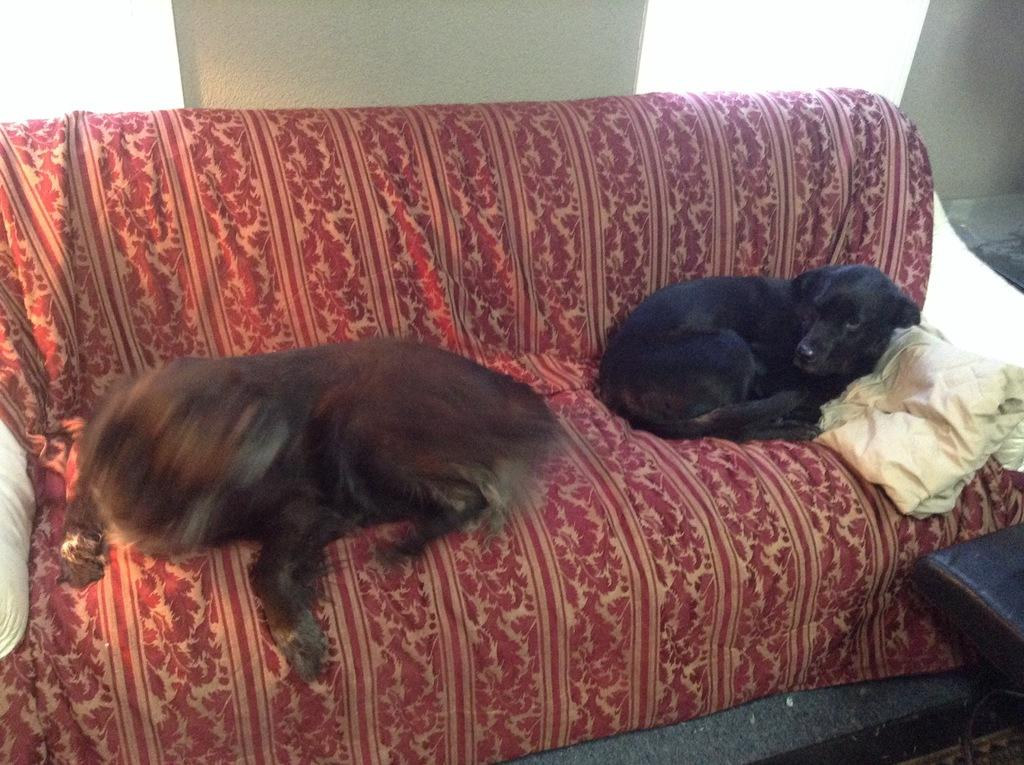What animals are lying on the sofa in the image? There are dogs lying on the sofa in the image. What is covering the sofa in the image? There is a blanket placed on the sofa. What can be seen in the background of the image? There is a wall in the background of the image. What is the name of the guitar player in the image? There is no guitar player present in the image; it features dogs lying on a sofa with a blanket. Can you tell me where the cellar is located in the image? There is no mention of a cellar in the image; it only shows dogs lying on a sofa with a blanket and a wall in the background. 